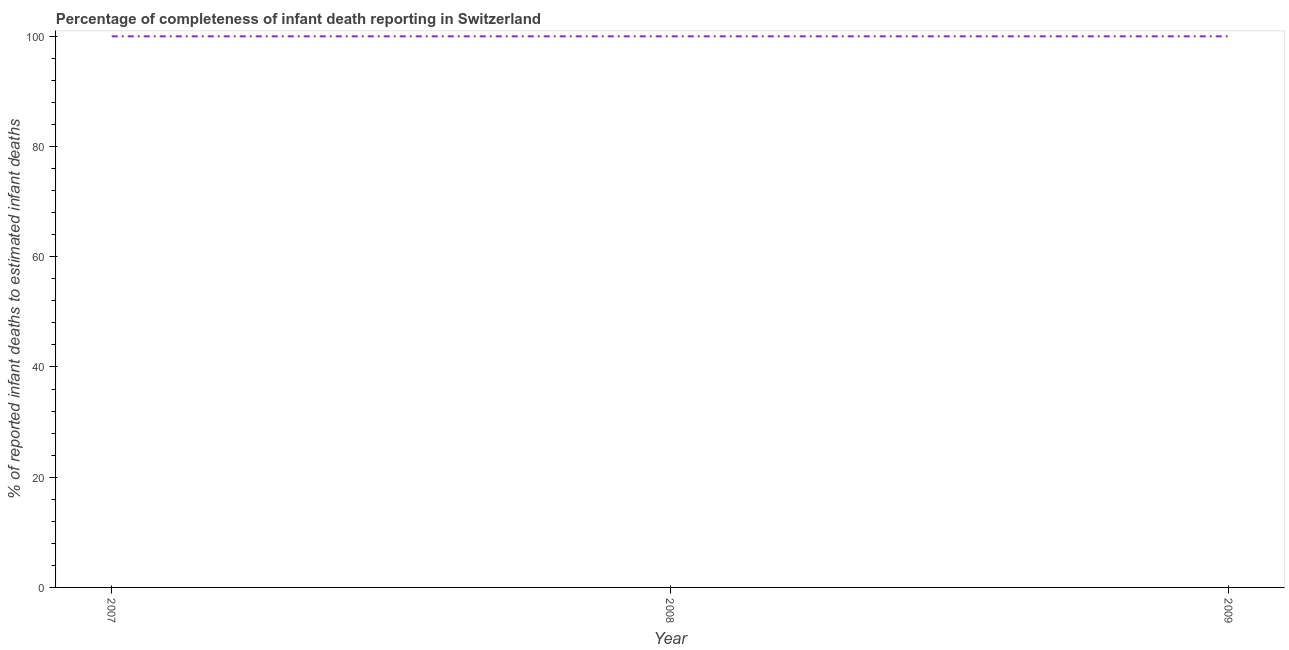What is the completeness of infant death reporting in 2009?
Your answer should be compact. 100. Across all years, what is the maximum completeness of infant death reporting?
Make the answer very short. 100. Across all years, what is the minimum completeness of infant death reporting?
Provide a short and direct response. 100. In which year was the completeness of infant death reporting minimum?
Provide a succinct answer. 2007. What is the sum of the completeness of infant death reporting?
Offer a very short reply. 300. In how many years, is the completeness of infant death reporting greater than 84 %?
Provide a succinct answer. 3. Is the sum of the completeness of infant death reporting in 2007 and 2008 greater than the maximum completeness of infant death reporting across all years?
Provide a succinct answer. Yes. How many lines are there?
Give a very brief answer. 1. What is the title of the graph?
Keep it short and to the point. Percentage of completeness of infant death reporting in Switzerland. What is the label or title of the X-axis?
Give a very brief answer. Year. What is the label or title of the Y-axis?
Your response must be concise. % of reported infant deaths to estimated infant deaths. What is the % of reported infant deaths to estimated infant deaths in 2009?
Your response must be concise. 100. What is the difference between the % of reported infant deaths to estimated infant deaths in 2007 and 2009?
Your response must be concise. 0. What is the difference between the % of reported infant deaths to estimated infant deaths in 2008 and 2009?
Provide a short and direct response. 0. What is the ratio of the % of reported infant deaths to estimated infant deaths in 2007 to that in 2008?
Your answer should be compact. 1. What is the ratio of the % of reported infant deaths to estimated infant deaths in 2007 to that in 2009?
Make the answer very short. 1. 